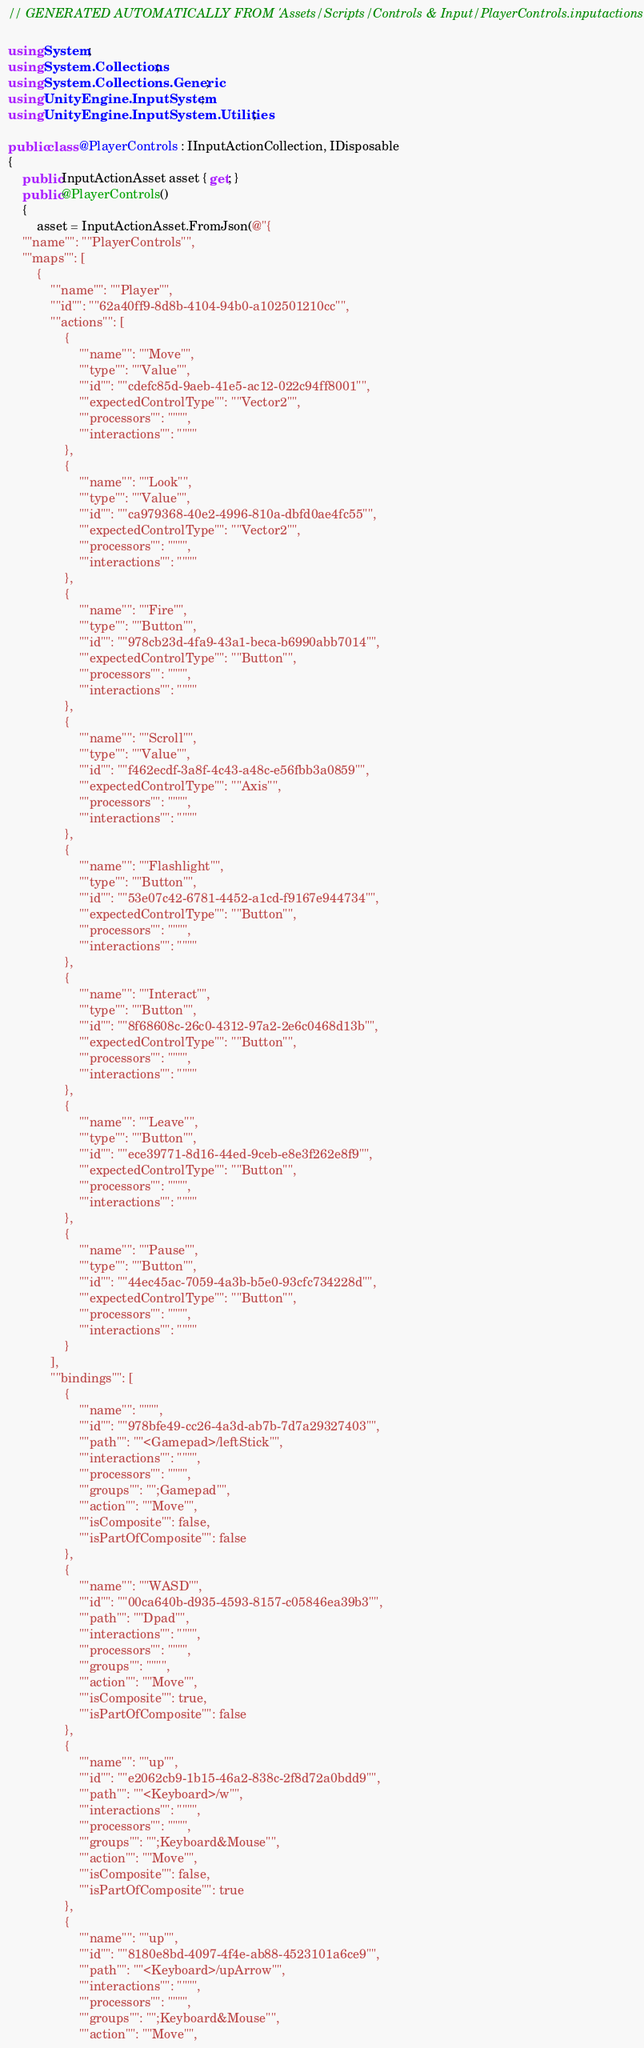<code> <loc_0><loc_0><loc_500><loc_500><_C#_>// GENERATED AUTOMATICALLY FROM 'Assets/Scripts/Controls & Input/PlayerControls.inputactions'

using System;
using System.Collections;
using System.Collections.Generic;
using UnityEngine.InputSystem;
using UnityEngine.InputSystem.Utilities;

public class @PlayerControls : IInputActionCollection, IDisposable
{
    public InputActionAsset asset { get; }
    public @PlayerControls()
    {
        asset = InputActionAsset.FromJson(@"{
    ""name"": ""PlayerControls"",
    ""maps"": [
        {
            ""name"": ""Player"",
            ""id"": ""62a40ff9-8d8b-4104-94b0-a102501210cc"",
            ""actions"": [
                {
                    ""name"": ""Move"",
                    ""type"": ""Value"",
                    ""id"": ""cdefc85d-9aeb-41e5-ac12-022c94ff8001"",
                    ""expectedControlType"": ""Vector2"",
                    ""processors"": """",
                    ""interactions"": """"
                },
                {
                    ""name"": ""Look"",
                    ""type"": ""Value"",
                    ""id"": ""ca979368-40e2-4996-810a-dbfd0ae4fc55"",
                    ""expectedControlType"": ""Vector2"",
                    ""processors"": """",
                    ""interactions"": """"
                },
                {
                    ""name"": ""Fire"",
                    ""type"": ""Button"",
                    ""id"": ""978cb23d-4fa9-43a1-beca-b6990abb7014"",
                    ""expectedControlType"": ""Button"",
                    ""processors"": """",
                    ""interactions"": """"
                },
                {
                    ""name"": ""Scroll"",
                    ""type"": ""Value"",
                    ""id"": ""f462ecdf-3a8f-4c43-a48c-e56fbb3a0859"",
                    ""expectedControlType"": ""Axis"",
                    ""processors"": """",
                    ""interactions"": """"
                },
                {
                    ""name"": ""Flashlight"",
                    ""type"": ""Button"",
                    ""id"": ""53e07c42-6781-4452-a1cd-f9167e944734"",
                    ""expectedControlType"": ""Button"",
                    ""processors"": """",
                    ""interactions"": """"
                },
                {
                    ""name"": ""Interact"",
                    ""type"": ""Button"",
                    ""id"": ""8f68608c-26c0-4312-97a2-2e6c0468d13b"",
                    ""expectedControlType"": ""Button"",
                    ""processors"": """",
                    ""interactions"": """"
                },
                {
                    ""name"": ""Leave"",
                    ""type"": ""Button"",
                    ""id"": ""ece39771-8d16-44ed-9ceb-e8e3f262e8f9"",
                    ""expectedControlType"": ""Button"",
                    ""processors"": """",
                    ""interactions"": """"
                },
                {
                    ""name"": ""Pause"",
                    ""type"": ""Button"",
                    ""id"": ""44ec45ac-7059-4a3b-b5e0-93cfc734228d"",
                    ""expectedControlType"": ""Button"",
                    ""processors"": """",
                    ""interactions"": """"
                }
            ],
            ""bindings"": [
                {
                    ""name"": """",
                    ""id"": ""978bfe49-cc26-4a3d-ab7b-7d7a29327403"",
                    ""path"": ""<Gamepad>/leftStick"",
                    ""interactions"": """",
                    ""processors"": """",
                    ""groups"": "";Gamepad"",
                    ""action"": ""Move"",
                    ""isComposite"": false,
                    ""isPartOfComposite"": false
                },
                {
                    ""name"": ""WASD"",
                    ""id"": ""00ca640b-d935-4593-8157-c05846ea39b3"",
                    ""path"": ""Dpad"",
                    ""interactions"": """",
                    ""processors"": """",
                    ""groups"": """",
                    ""action"": ""Move"",
                    ""isComposite"": true,
                    ""isPartOfComposite"": false
                },
                {
                    ""name"": ""up"",
                    ""id"": ""e2062cb9-1b15-46a2-838c-2f8d72a0bdd9"",
                    ""path"": ""<Keyboard>/w"",
                    ""interactions"": """",
                    ""processors"": """",
                    ""groups"": "";Keyboard&Mouse"",
                    ""action"": ""Move"",
                    ""isComposite"": false,
                    ""isPartOfComposite"": true
                },
                {
                    ""name"": ""up"",
                    ""id"": ""8180e8bd-4097-4f4e-ab88-4523101a6ce9"",
                    ""path"": ""<Keyboard>/upArrow"",
                    ""interactions"": """",
                    ""processors"": """",
                    ""groups"": "";Keyboard&Mouse"",
                    ""action"": ""Move"",</code> 